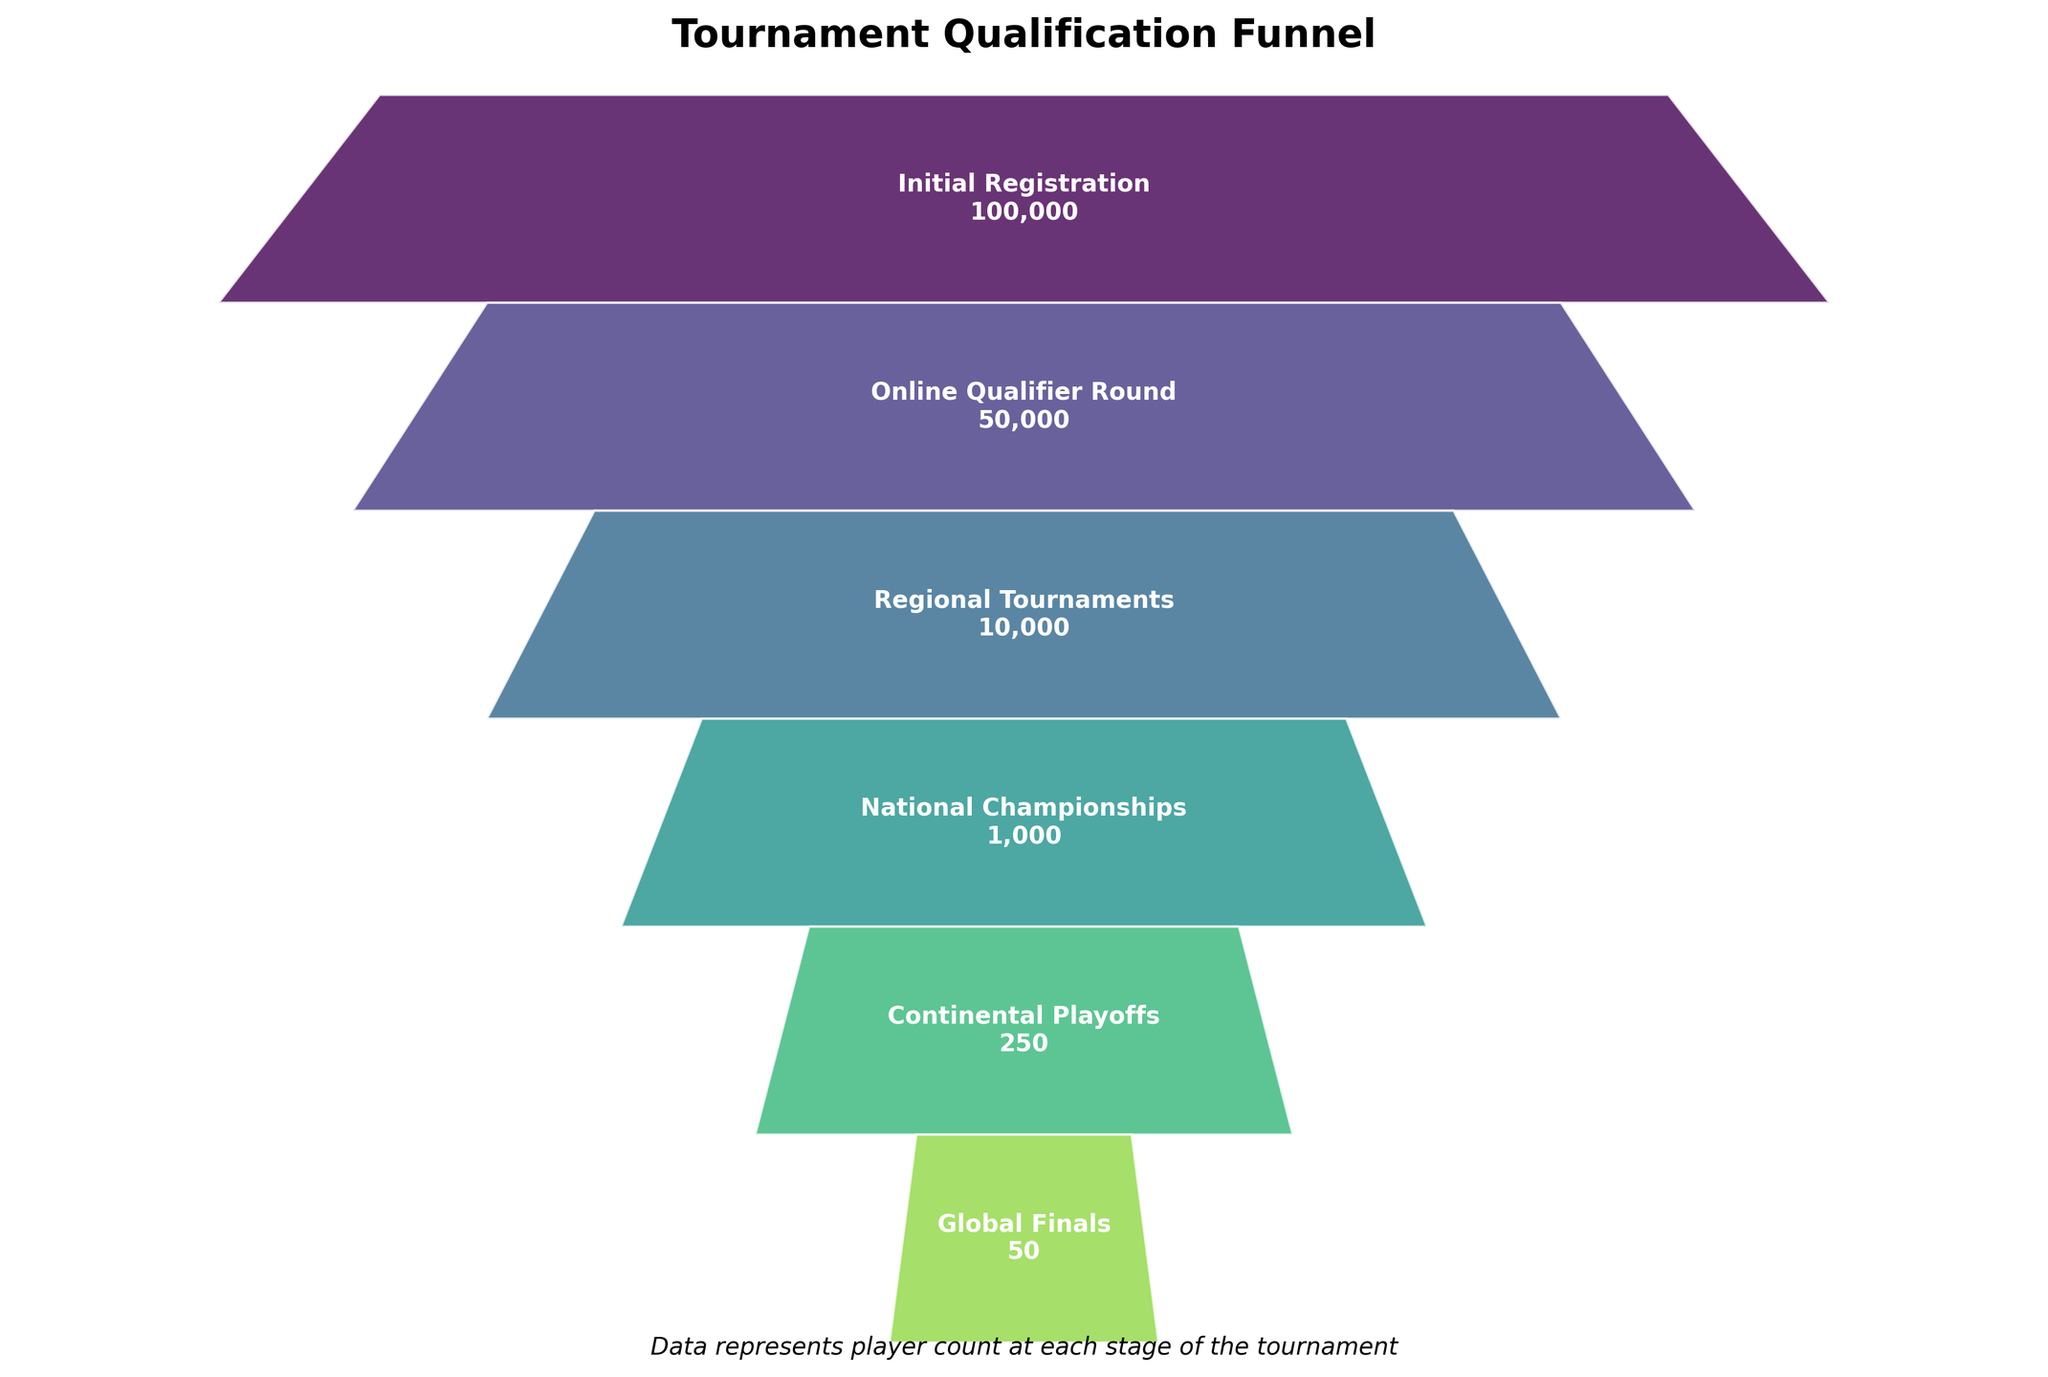What is the title of the funnel chart? The title of the funnel chart is located at the top of the figure. By looking at the visual provided, the title reads "Tournament Qualification Funnel".
Answer: Tournament Qualification Funnel How many stages are there in the tournament qualification process? Counting the number of visual segments in the funnel chart, we can see there are six distinct stages.
Answer: 6 Which stage has the highest number of players? Each stage label includes the number of players. The segment named "Initial Registration" states 100,000 players, which is the highest.
Answer: Initial Registration How many players advance from the National Championships to the Continental Playoffs? To find this, look at the "National Championships" and "Continental Playoffs" segments. The number of players in the National Championships is 1,000, and it decreases to 250 for the Continental Playoffs. The difference is 1,000 - 250 = 750.
Answer: 750 Compare the number of players from the Online Qualifier Round to the Regional Tournaments. Which stage has fewer players and by how much? The Online Qualifier Round has 50,000 players, and the Regional Tournaments have 10,000 players. Regional Tournaments have fewer players, and the difference is 50,000 - 10,000 = 40,000.
Answer: Regional Tournaments, 40,000 What percentage of initial registrants make it to the Global Finals? The Initial Registration has 100,000 players, while the Global Finals have 50 players. The percentage is calculated by (50 / 100,000) * 100 = 0.05%.
Answer: 0.05% From which stage do the player numbers decrease the most? By finding the largest drop between consecutive stages, we observe the change from the Online Qualifier Round (50,000) to the Regional Tournaments (10,000) is 50,000 - 10,000 = 40,000, which is the largest decrease.
Answer: Online Qualifier Round to Regional Tournaments What color scheme is used to represent the stages in the funnel chart? Observing the funnel chart, it's clear that a gradient color scheme from the viridis colormap is used, transitioning through various hues.
Answer: viridis gradient What is the combined number of players in the Regional Tournaments, National Championships, and Continental Playoffs stages? Adding together the number of players in these stages: 10,000 (Regional Tournaments) + 1,000 (National Championships) + 250 (Continental Playoffs) = 11,250.
Answer: 11,250 How many players are filtered out between the Continental Playoffs and the Global Finals? Subtracting the number of players in the Global Finals (50) from those in the Continental Playoffs (250) yields: 250 - 50 = 200.
Answer: 200 